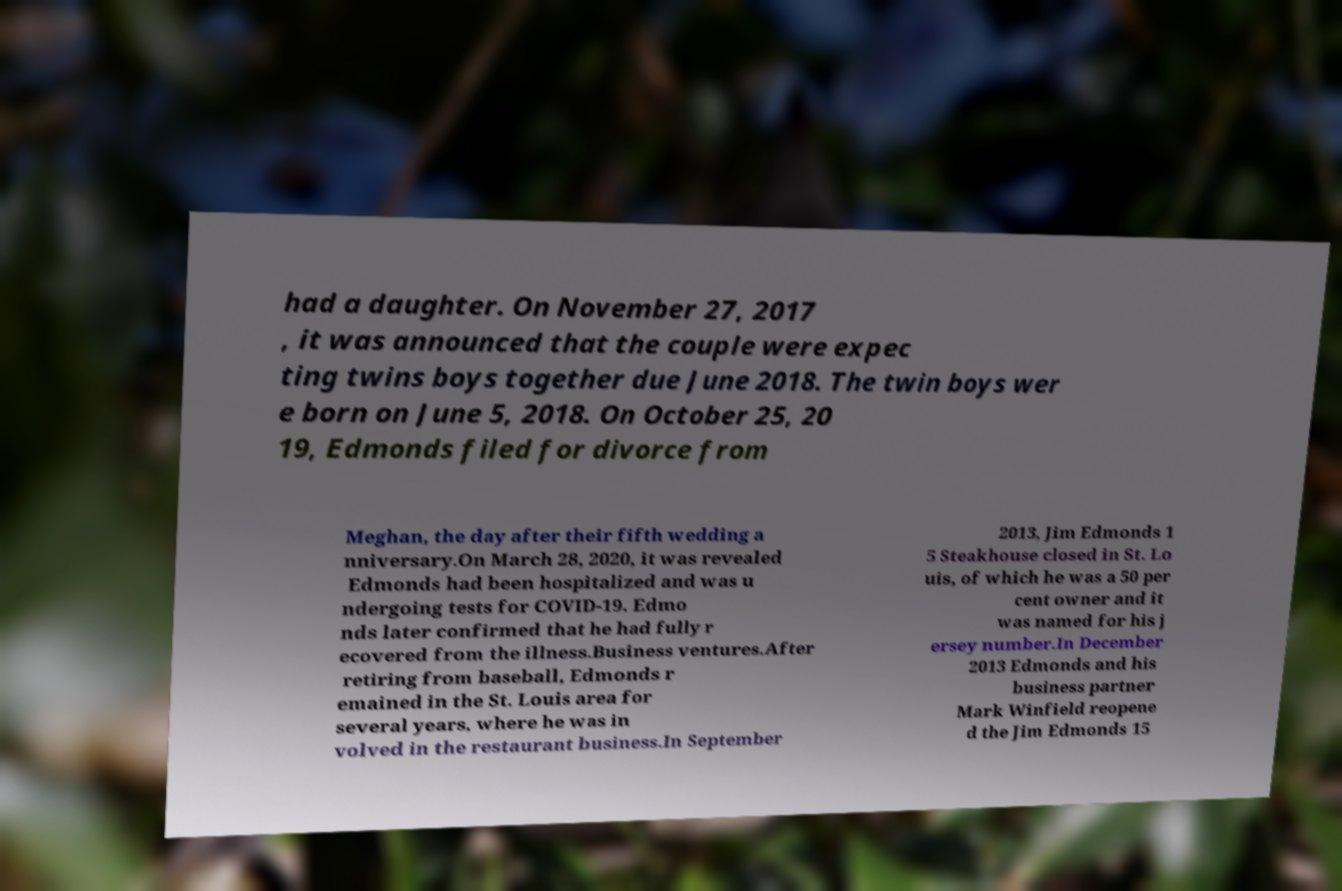Please identify and transcribe the text found in this image. had a daughter. On November 27, 2017 , it was announced that the couple were expec ting twins boys together due June 2018. The twin boys wer e born on June 5, 2018. On October 25, 20 19, Edmonds filed for divorce from Meghan, the day after their fifth wedding a nniversary.On March 28, 2020, it was revealed Edmonds had been hospitalized and was u ndergoing tests for COVID-19. Edmo nds later confirmed that he had fully r ecovered from the illness.Business ventures.After retiring from baseball, Edmonds r emained in the St. Louis area for several years, where he was in volved in the restaurant business.In September 2013, Jim Edmonds 1 5 Steakhouse closed in St. Lo uis, of which he was a 50 per cent owner and it was named for his j ersey number.In December 2013 Edmonds and his business partner Mark Winfield reopene d the Jim Edmonds 15 